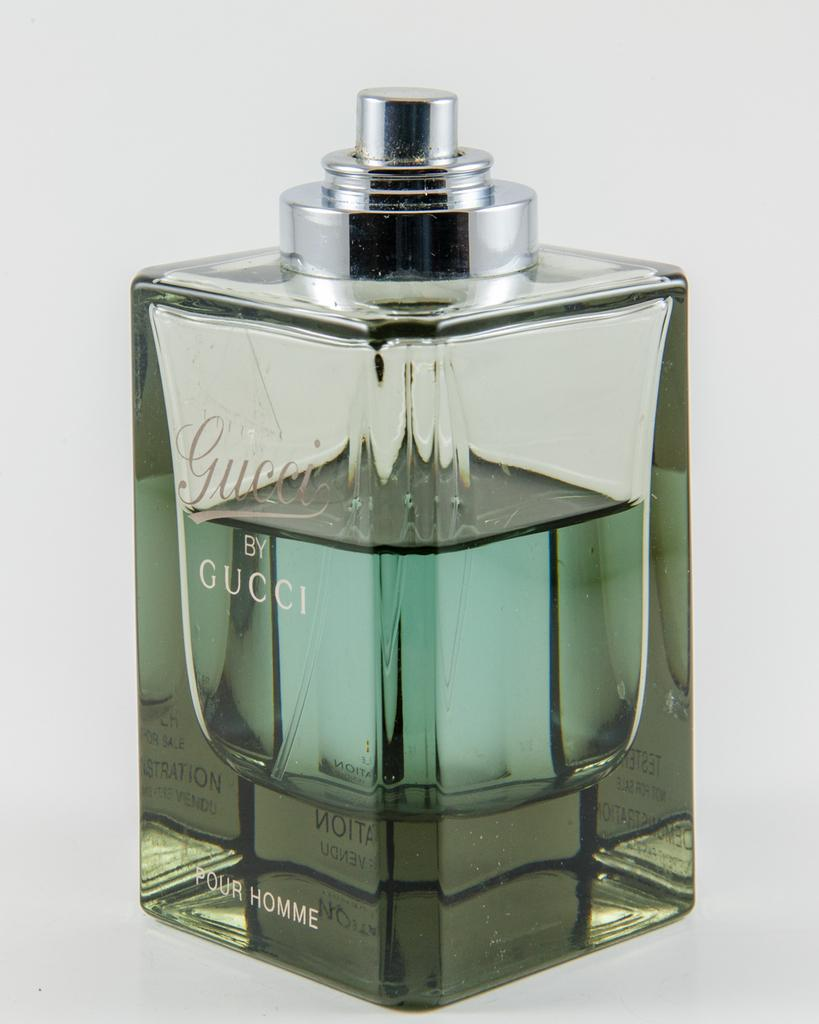<image>
Present a compact description of the photo's key features. a clear glass bottle of Gucci by Gucci perfume 